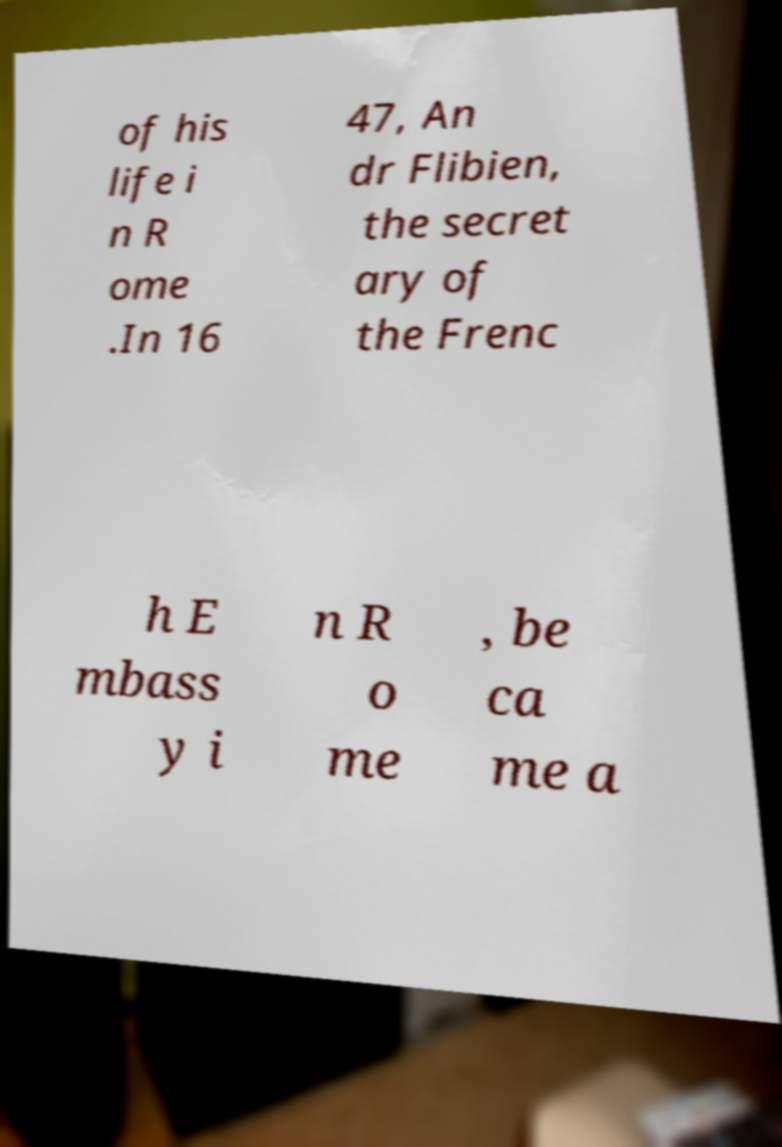For documentation purposes, I need the text within this image transcribed. Could you provide that? of his life i n R ome .In 16 47, An dr Flibien, the secret ary of the Frenc h E mbass y i n R o me , be ca me a 